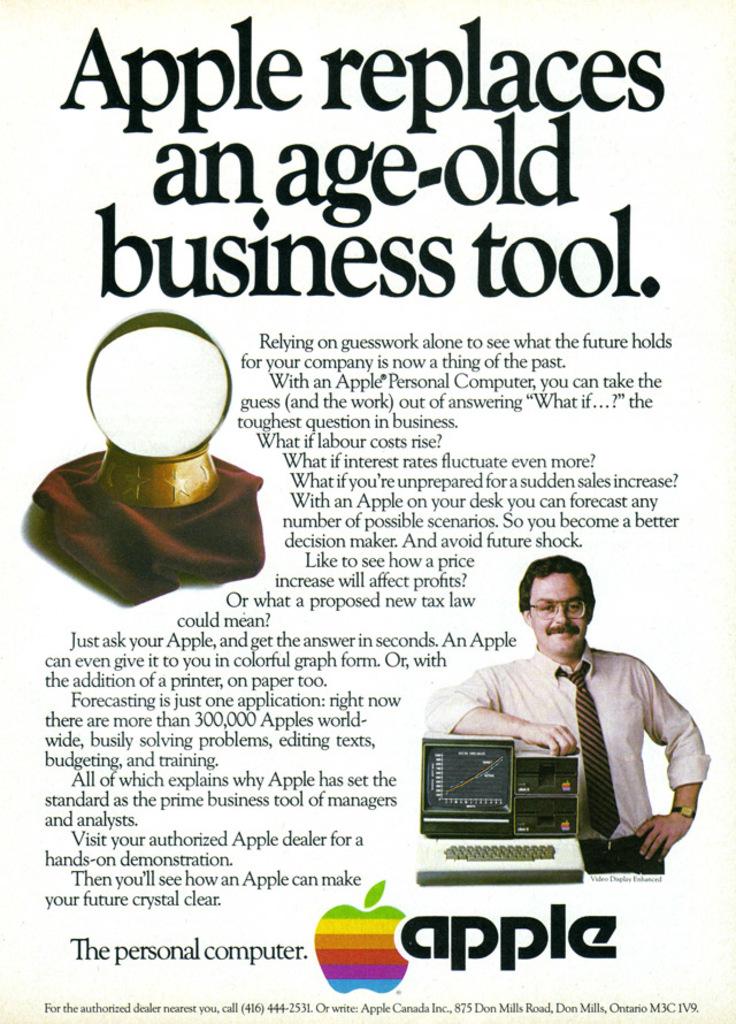What brand is advertised?
Offer a very short reply. Apple. Apple replaces what?
Your response must be concise. An age-old business tool. 